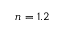Convert formula to latex. <formula><loc_0><loc_0><loc_500><loc_500>n = 1 . 2</formula> 